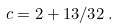<formula> <loc_0><loc_0><loc_500><loc_500>c = 2 + 1 3 / 3 2 \, .</formula> 